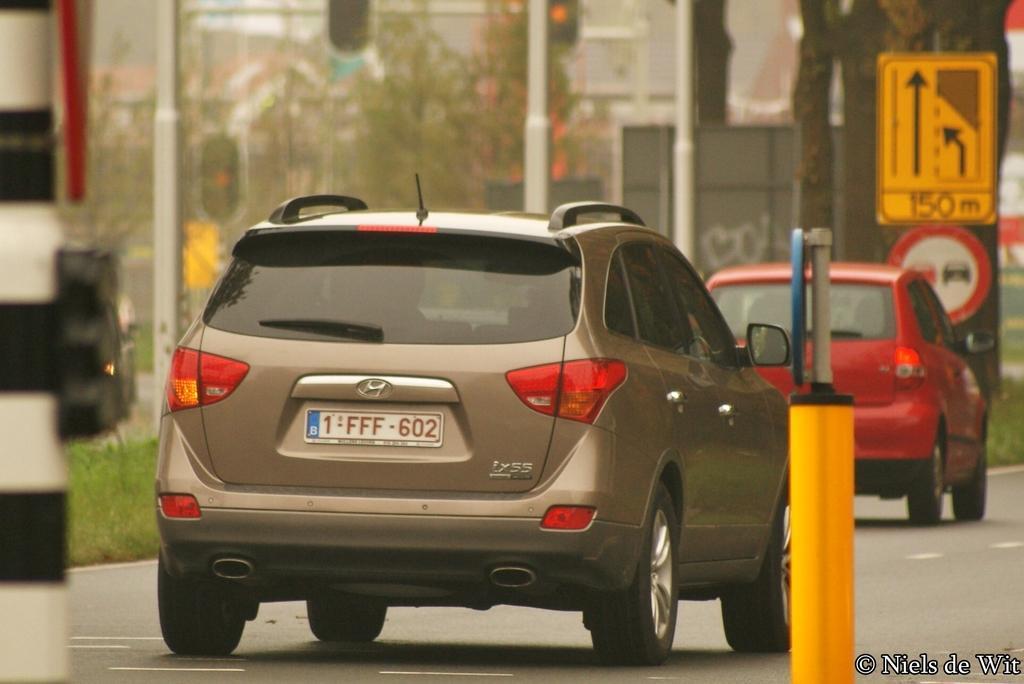Please provide a concise description of this image. In this image there are cars on a road, in the background there are poles, trees, boards and it is blurred, in the bottom right there is text. 